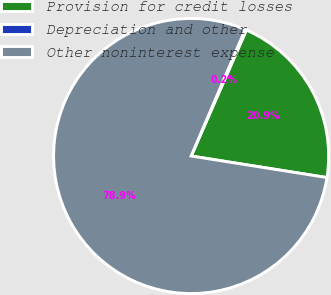Convert chart. <chart><loc_0><loc_0><loc_500><loc_500><pie_chart><fcel>Provision for credit losses<fcel>Depreciation and other<fcel>Other noninterest expense<nl><fcel>20.93%<fcel>0.15%<fcel>78.92%<nl></chart> 